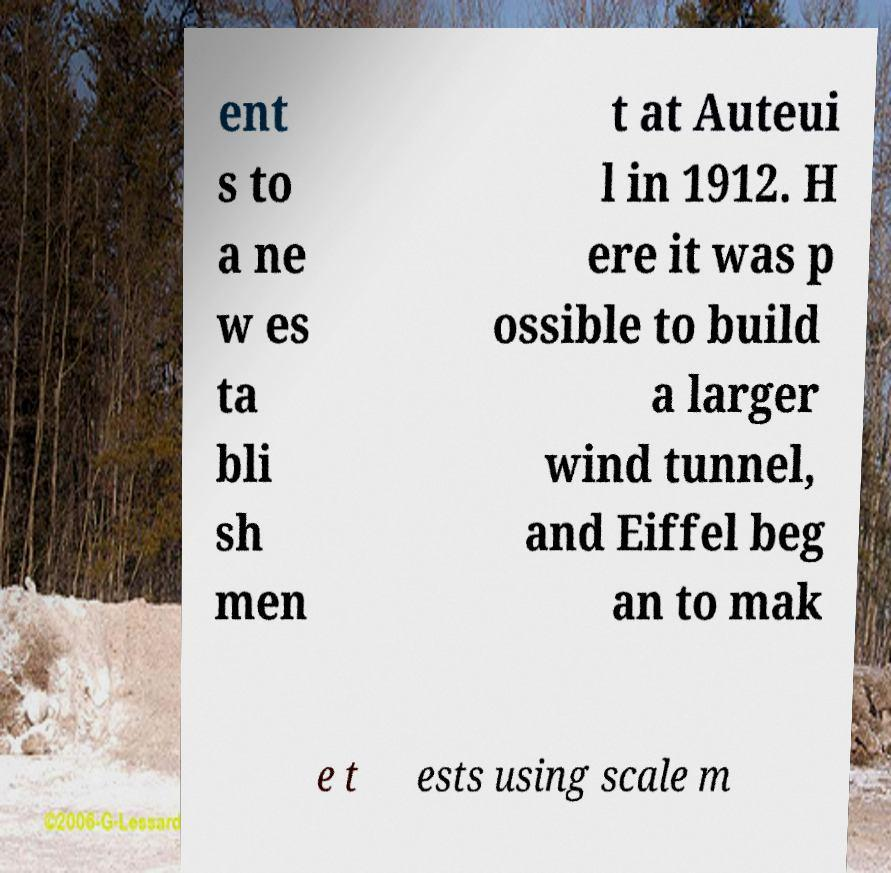For documentation purposes, I need the text within this image transcribed. Could you provide that? ent s to a ne w es ta bli sh men t at Auteui l in 1912. H ere it was p ossible to build a larger wind tunnel, and Eiffel beg an to mak e t ests using scale m 